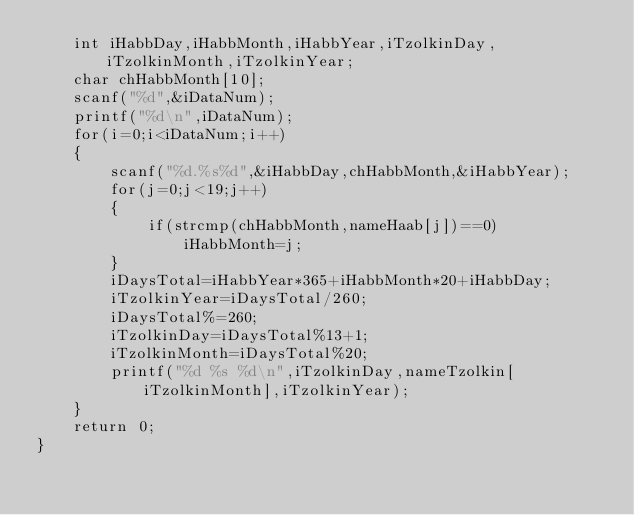<code> <loc_0><loc_0><loc_500><loc_500><_C++_>	int iHabbDay,iHabbMonth,iHabbYear,iTzolkinDay,iTzolkinMonth,iTzolkinYear;
	char chHabbMonth[10];
	scanf("%d",&iDataNum);
	printf("%d\n",iDataNum);
	for(i=0;i<iDataNum;i++)
	{
		scanf("%d.%s%d",&iHabbDay,chHabbMonth,&iHabbYear);
		for(j=0;j<19;j++)
		{
			if(strcmp(chHabbMonth,nameHaab[j])==0)
				iHabbMonth=j;
		}
		iDaysTotal=iHabbYear*365+iHabbMonth*20+iHabbDay;
		iTzolkinYear=iDaysTotal/260;
		iDaysTotal%=260;
		iTzolkinDay=iDaysTotal%13+1;
		iTzolkinMonth=iDaysTotal%20;
		printf("%d %s %d\n",iTzolkinDay,nameTzolkin[iTzolkinMonth],iTzolkinYear);
	}
	return 0;
}</code> 